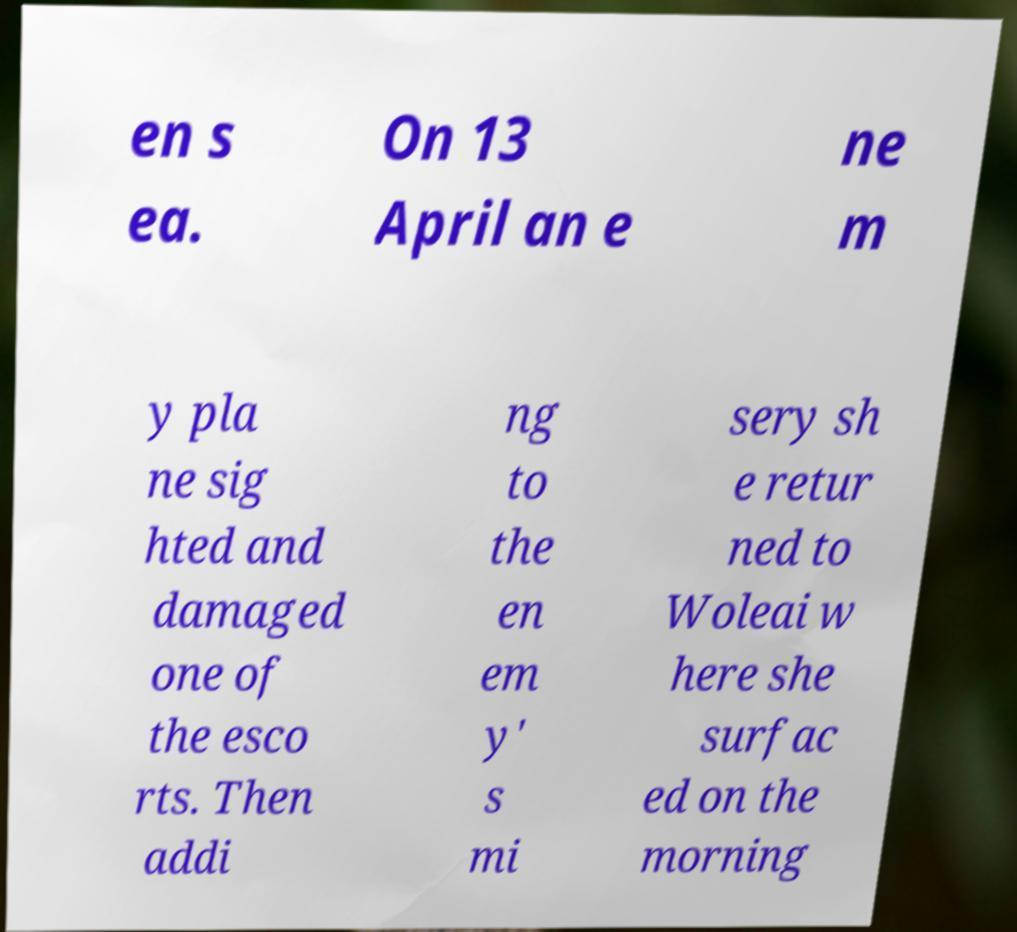Can you accurately transcribe the text from the provided image for me? en s ea. On 13 April an e ne m y pla ne sig hted and damaged one of the esco rts. Then addi ng to the en em y' s mi sery sh e retur ned to Woleai w here she surfac ed on the morning 